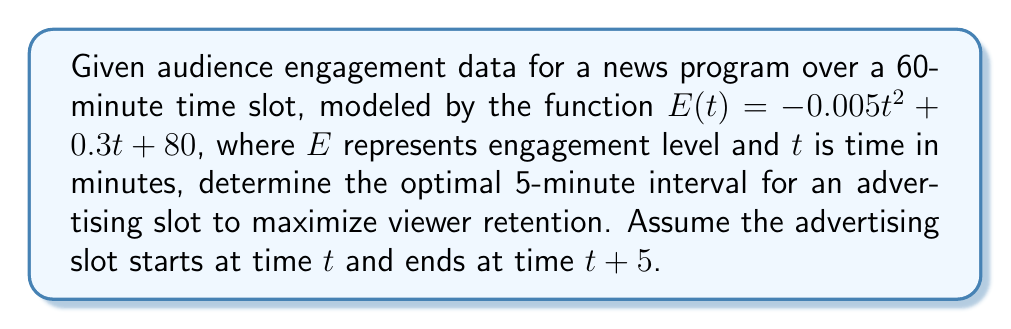Could you help me with this problem? 1) To find the optimal 5-minute interval, we need to maximize the average engagement over this interval. This can be done by maximizing the integral of $E(t)$ over the interval $[t, t+5]$, divided by the interval length.

2) The average engagement over the interval $[t, t+5]$ is given by:

   $$A(t) = \frac{1}{5} \int_t^{t+5} E(x) dx$$

3) Substituting the given function:

   $$A(t) = \frac{1}{5} \int_t^{t+5} (-0.005x^2 + 0.3x + 80) dx$$

4) Evaluating the integral:

   $$A(t) = \frac{1}{5} \left[-\frac{0.005}{3}x^3 + 0.15x^2 + 80x\right]_t^{t+5}$$

5) Simplifying:

   $$A(t) = -\frac{1}{300}t^2 + \frac{1}{10}t + \frac{625}{60} + 80$$

6) To find the maximum of $A(t)$, we differentiate and set to zero:

   $$A'(t) = -\frac{1}{150}t + \frac{1}{10} = 0$$

7) Solving for $t$:

   $$t = 15$$

8) The second derivative $A''(t) = -\frac{1}{150}$ is negative, confirming this is a maximum.

9) Therefore, the optimal 5-minute interval starts at $t = 15$ minutes into the program.
Answer: 15-20 minutes 